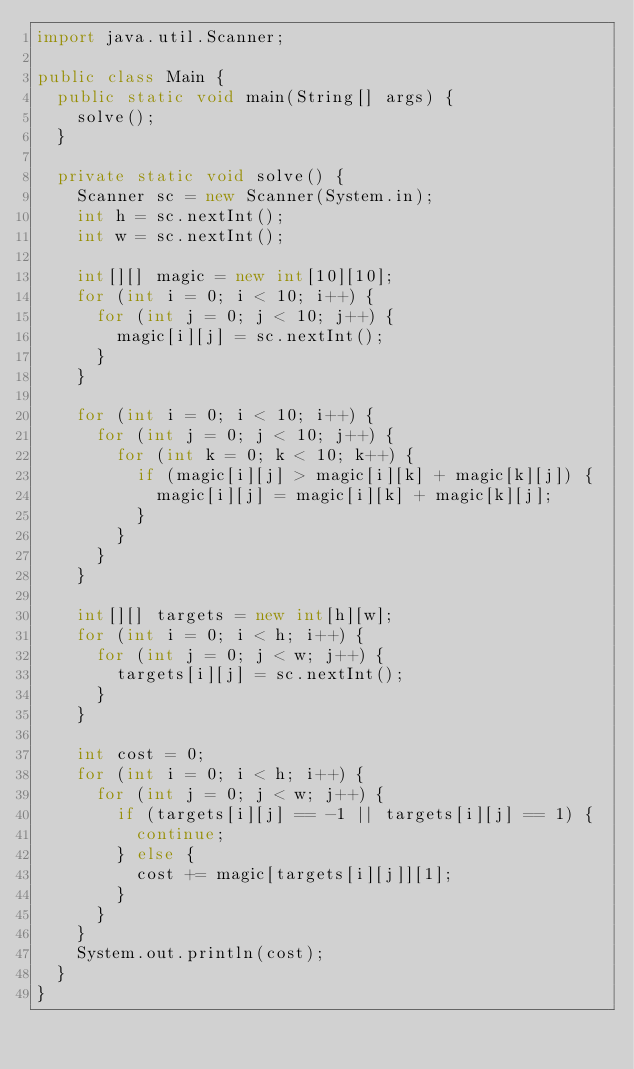Convert code to text. <code><loc_0><loc_0><loc_500><loc_500><_Java_>import java.util.Scanner;

public class Main {
	public static void main(String[] args) {
		solve();
	}

	private static void solve() {
		Scanner sc = new Scanner(System.in);
		int h = sc.nextInt();
		int w = sc.nextInt();

		int[][] magic = new int[10][10];
		for (int i = 0; i < 10; i++) {
			for (int j = 0; j < 10; j++) {
				magic[i][j] = sc.nextInt();
			}
		}

		for (int i = 0; i < 10; i++) {
			for (int j = 0; j < 10; j++) {
				for (int k = 0; k < 10; k++) {
					if (magic[i][j] > magic[i][k] + magic[k][j]) {
						magic[i][j] = magic[i][k] + magic[k][j];
					}
				}
			}
		}

		int[][] targets = new int[h][w];
		for (int i = 0; i < h; i++) {
			for (int j = 0; j < w; j++) {
				targets[i][j] = sc.nextInt();
			}
		}

		int cost = 0;
		for (int i = 0; i < h; i++) {
			for (int j = 0; j < w; j++) {
				if (targets[i][j] == -1 || targets[i][j] == 1) {
					continue;
				} else {
					cost += magic[targets[i][j]][1];
				}
			}
		}
		System.out.println(cost);
	}
}</code> 